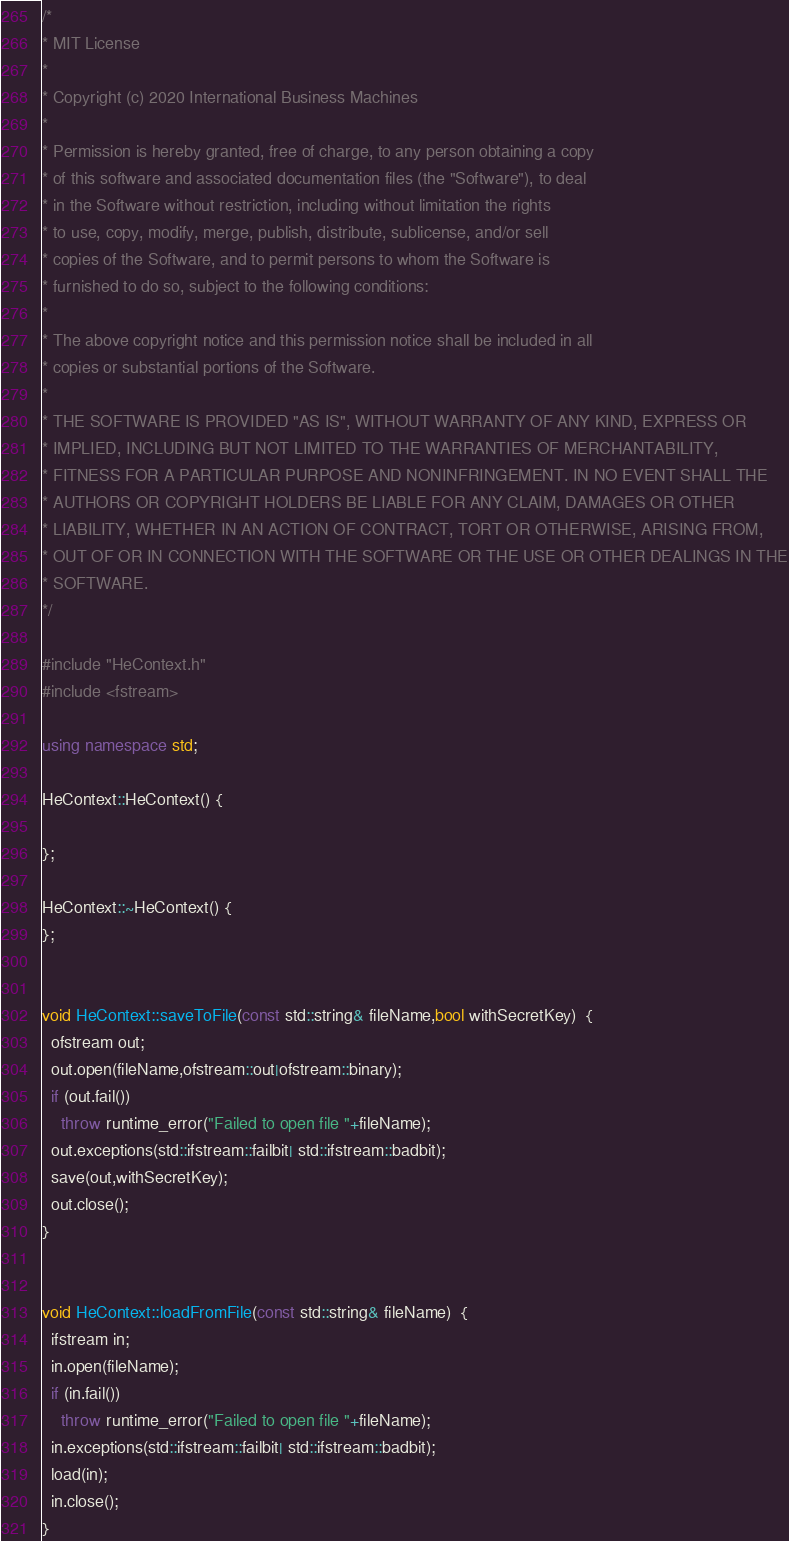Convert code to text. <code><loc_0><loc_0><loc_500><loc_500><_C++_>/*
* MIT License
*
* Copyright (c) 2020 International Business Machines
*
* Permission is hereby granted, free of charge, to any person obtaining a copy
* of this software and associated documentation files (the "Software"), to deal
* in the Software without restriction, including without limitation the rights
* to use, copy, modify, merge, publish, distribute, sublicense, and/or sell
* copies of the Software, and to permit persons to whom the Software is
* furnished to do so, subject to the following conditions:
*
* The above copyright notice and this permission notice shall be included in all
* copies or substantial portions of the Software.
*
* THE SOFTWARE IS PROVIDED "AS IS", WITHOUT WARRANTY OF ANY KIND, EXPRESS OR
* IMPLIED, INCLUDING BUT NOT LIMITED TO THE WARRANTIES OF MERCHANTABILITY,
* FITNESS FOR A PARTICULAR PURPOSE AND NONINFRINGEMENT. IN NO EVENT SHALL THE
* AUTHORS OR COPYRIGHT HOLDERS BE LIABLE FOR ANY CLAIM, DAMAGES OR OTHER
* LIABILITY, WHETHER IN AN ACTION OF CONTRACT, TORT OR OTHERWISE, ARISING FROM,
* OUT OF OR IN CONNECTION WITH THE SOFTWARE OR THE USE OR OTHER DEALINGS IN THE
* SOFTWARE.
*/

#include "HeContext.h"
#include <fstream>

using namespace std;

HeContext::HeContext() {
 
};

HeContext::~HeContext() {
};


void HeContext::saveToFile(const std::string& fileName,bool withSecretKey)  {
  ofstream out;
  out.open(fileName,ofstream::out|ofstream::binary);
  if (out.fail())
    throw runtime_error("Failed to open file "+fileName);
  out.exceptions(std::ifstream::failbit| std::ifstream::badbit);
  save(out,withSecretKey);
  out.close();
}


void HeContext::loadFromFile(const std::string& fileName)  {
  ifstream in;
  in.open(fileName);
  if (in.fail())
    throw runtime_error("Failed to open file "+fileName);
  in.exceptions(std::ifstream::failbit| std::ifstream::badbit);
  load(in);
  in.close();
}


</code> 